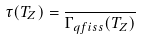<formula> <loc_0><loc_0><loc_500><loc_500>\tau ( T _ { Z } ) = \frac { } { \Gamma _ { q f i s s } ( T _ { Z } ) }</formula> 